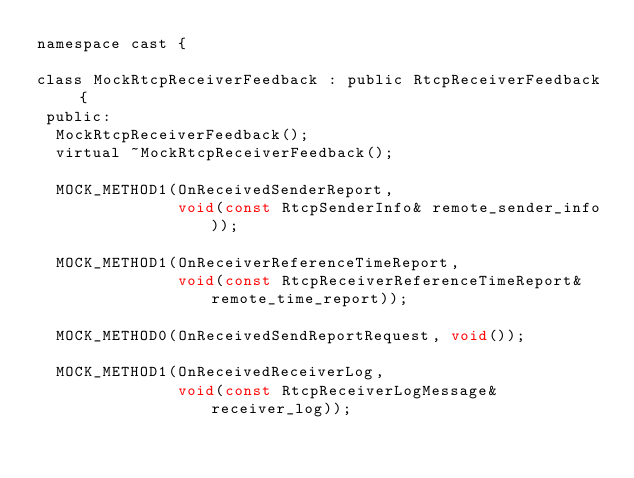<code> <loc_0><loc_0><loc_500><loc_500><_C_>namespace cast {

class MockRtcpReceiverFeedback : public RtcpReceiverFeedback {
 public:
  MockRtcpReceiverFeedback();
  virtual ~MockRtcpReceiverFeedback();

  MOCK_METHOD1(OnReceivedSenderReport,
               void(const RtcpSenderInfo& remote_sender_info));

  MOCK_METHOD1(OnReceiverReferenceTimeReport,
               void(const RtcpReceiverReferenceTimeReport& remote_time_report));

  MOCK_METHOD0(OnReceivedSendReportRequest, void());

  MOCK_METHOD1(OnReceivedReceiverLog,
               void(const RtcpReceiverLogMessage& receiver_log));</code> 